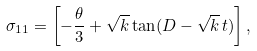Convert formula to latex. <formula><loc_0><loc_0><loc_500><loc_500>\sigma _ { 1 1 } = \left [ - \frac { \theta } { 3 } + \sqrt { k } \tan ( D - { \sqrt { k } } \, t ) \right ] ,</formula> 